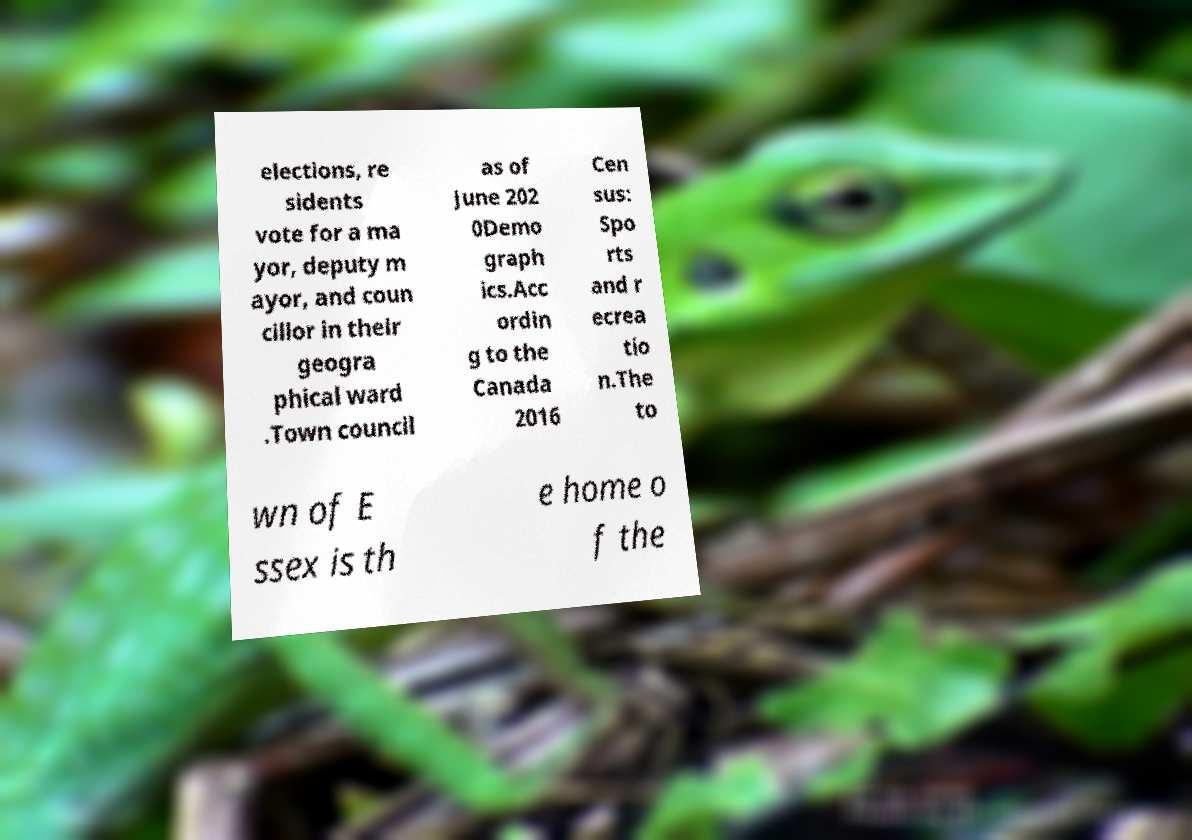Could you assist in decoding the text presented in this image and type it out clearly? elections, re sidents vote for a ma yor, deputy m ayor, and coun cillor in their geogra phical ward .Town council as of June 202 0Demo graph ics.Acc ordin g to the Canada 2016 Cen sus: Spo rts and r ecrea tio n.The to wn of E ssex is th e home o f the 